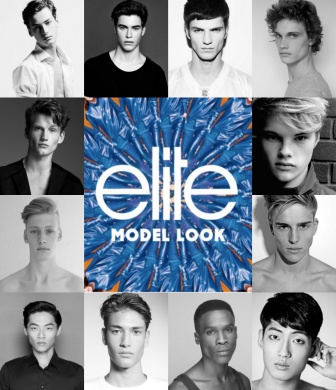Imagine the central logo is a portal. Where does it lead? Imagining the central logo as a portal, it could lead to an extraordinary world where fashion meets fantasy. The models are transported into a visually stunning, ethereal landscape filled with surreal elements like floating catwalks, fashion-forward mythical creatures, and a sky painted in ever-changing hues of blue and orange. This magical realm is a place where creativity knows no bounds, and each model embarks on an adventure that showcases their unique talents and styles in enchanting and imaginative ways. 